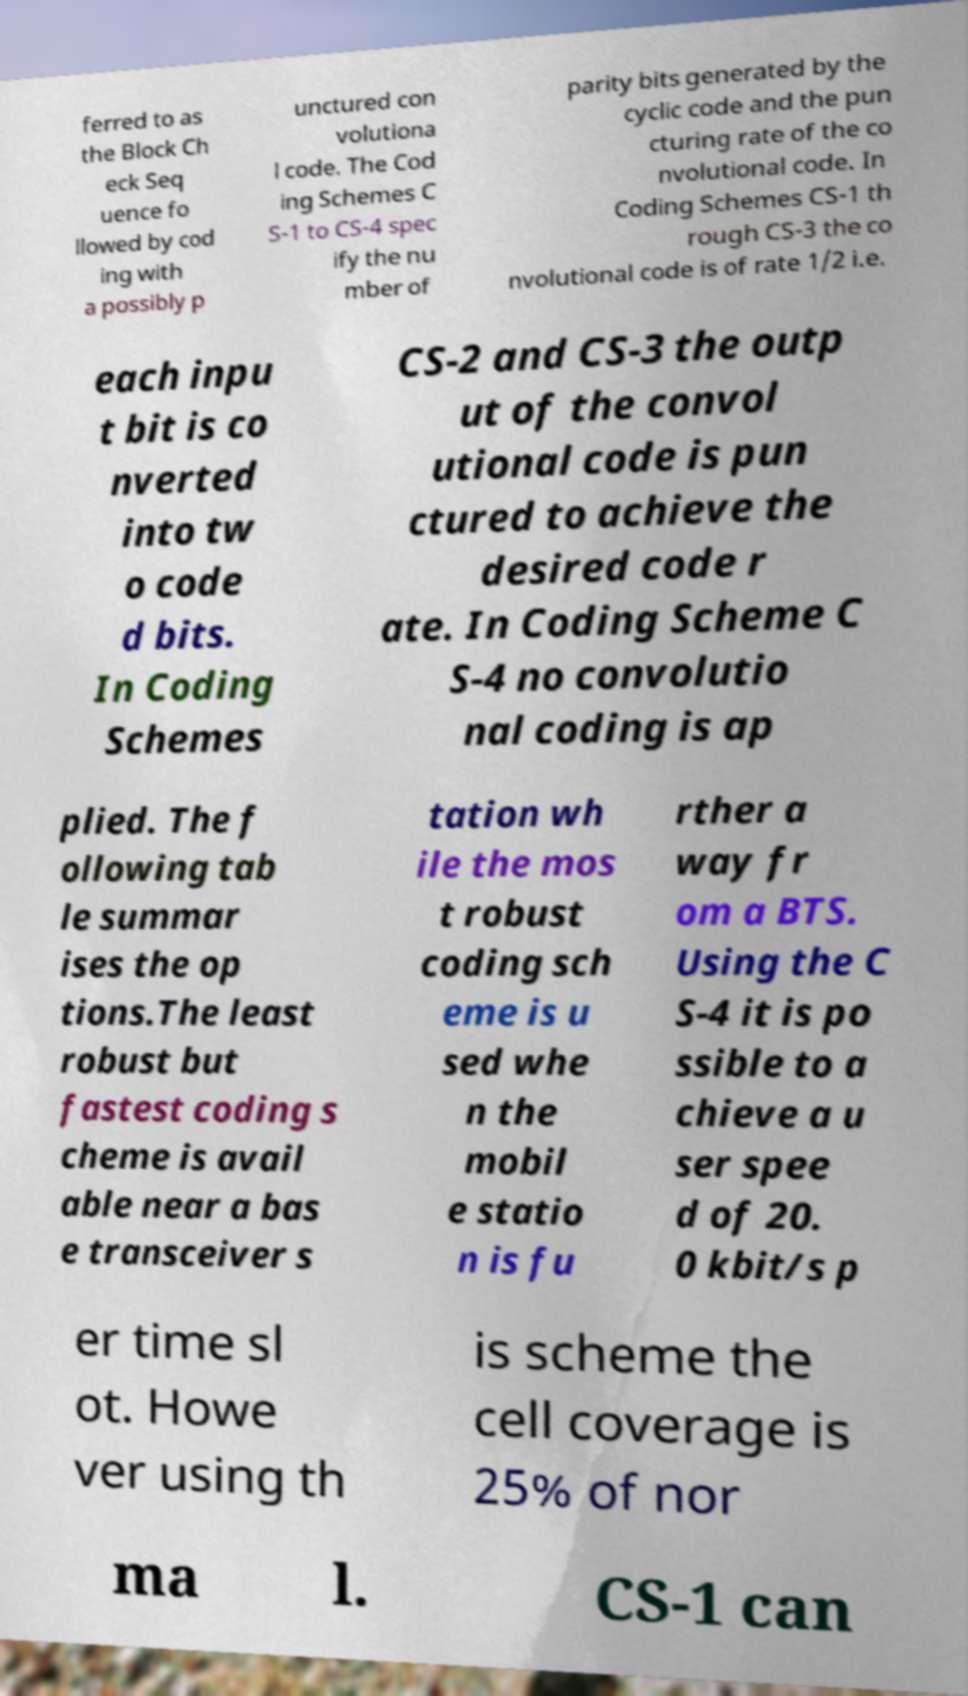Please identify and transcribe the text found in this image. ferred to as the Block Ch eck Seq uence fo llowed by cod ing with a possibly p unctured con volutiona l code. The Cod ing Schemes C S-1 to CS-4 spec ify the nu mber of parity bits generated by the cyclic code and the pun cturing rate of the co nvolutional code. In Coding Schemes CS-1 th rough CS-3 the co nvolutional code is of rate 1/2 i.e. each inpu t bit is co nverted into tw o code d bits. In Coding Schemes CS-2 and CS-3 the outp ut of the convol utional code is pun ctured to achieve the desired code r ate. In Coding Scheme C S-4 no convolutio nal coding is ap plied. The f ollowing tab le summar ises the op tions.The least robust but fastest coding s cheme is avail able near a bas e transceiver s tation wh ile the mos t robust coding sch eme is u sed whe n the mobil e statio n is fu rther a way fr om a BTS. Using the C S-4 it is po ssible to a chieve a u ser spee d of 20. 0 kbit/s p er time sl ot. Howe ver using th is scheme the cell coverage is 25% of nor ma l. CS-1 can 